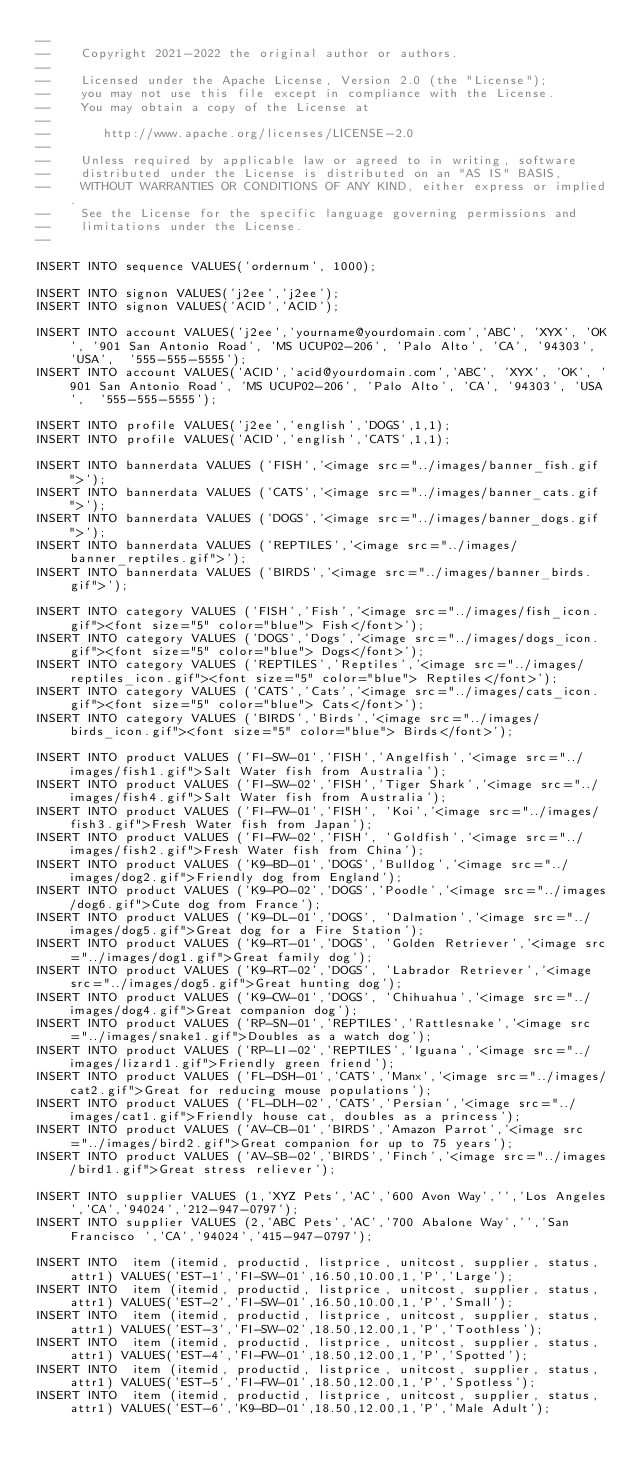Convert code to text. <code><loc_0><loc_0><loc_500><loc_500><_SQL_>--
--    Copyright 2021-2022 the original author or authors.
--
--    Licensed under the Apache License, Version 2.0 (the "License");
--    you may not use this file except in compliance with the License.
--    You may obtain a copy of the License at
--
--       http://www.apache.org/licenses/LICENSE-2.0
--
--    Unless required by applicable law or agreed to in writing, software
--    distributed under the License is distributed on an "AS IS" BASIS,
--    WITHOUT WARRANTIES OR CONDITIONS OF ANY KIND, either express or implied.
--    See the License for the specific language governing permissions and
--    limitations under the License.
--

INSERT INTO sequence VALUES('ordernum', 1000);

INSERT INTO signon VALUES('j2ee','j2ee');
INSERT INTO signon VALUES('ACID','ACID');

INSERT INTO account VALUES('j2ee','yourname@yourdomain.com','ABC', 'XYX', 'OK', '901 San Antonio Road', 'MS UCUP02-206', 'Palo Alto', 'CA', '94303', 'USA',  '555-555-5555');
INSERT INTO account VALUES('ACID','acid@yourdomain.com','ABC', 'XYX', 'OK', '901 San Antonio Road', 'MS UCUP02-206', 'Palo Alto', 'CA', '94303', 'USA',  '555-555-5555');

INSERT INTO profile VALUES('j2ee','english','DOGS',1,1);
INSERT INTO profile VALUES('ACID','english','CATS',1,1);

INSERT INTO bannerdata VALUES ('FISH','<image src="../images/banner_fish.gif">');
INSERT INTO bannerdata VALUES ('CATS','<image src="../images/banner_cats.gif">');
INSERT INTO bannerdata VALUES ('DOGS','<image src="../images/banner_dogs.gif">');
INSERT INTO bannerdata VALUES ('REPTILES','<image src="../images/banner_reptiles.gif">');
INSERT INTO bannerdata VALUES ('BIRDS','<image src="../images/banner_birds.gif">');

INSERT INTO category VALUES ('FISH','Fish','<image src="../images/fish_icon.gif"><font size="5" color="blue"> Fish</font>');
INSERT INTO category VALUES ('DOGS','Dogs','<image src="../images/dogs_icon.gif"><font size="5" color="blue"> Dogs</font>');
INSERT INTO category VALUES ('REPTILES','Reptiles','<image src="../images/reptiles_icon.gif"><font size="5" color="blue"> Reptiles</font>');
INSERT INTO category VALUES ('CATS','Cats','<image src="../images/cats_icon.gif"><font size="5" color="blue"> Cats</font>');
INSERT INTO category VALUES ('BIRDS','Birds','<image src="../images/birds_icon.gif"><font size="5" color="blue"> Birds</font>');

INSERT INTO product VALUES ('FI-SW-01','FISH','Angelfish','<image src="../images/fish1.gif">Salt Water fish from Australia');
INSERT INTO product VALUES ('FI-SW-02','FISH','Tiger Shark','<image src="../images/fish4.gif">Salt Water fish from Australia');
INSERT INTO product VALUES ('FI-FW-01','FISH', 'Koi','<image src="../images/fish3.gif">Fresh Water fish from Japan');
INSERT INTO product VALUES ('FI-FW-02','FISH', 'Goldfish','<image src="../images/fish2.gif">Fresh Water fish from China');
INSERT INTO product VALUES ('K9-BD-01','DOGS','Bulldog','<image src="../images/dog2.gif">Friendly dog from England');
INSERT INTO product VALUES ('K9-PO-02','DOGS','Poodle','<image src="../images/dog6.gif">Cute dog from France');
INSERT INTO product VALUES ('K9-DL-01','DOGS', 'Dalmation','<image src="../images/dog5.gif">Great dog for a Fire Station');
INSERT INTO product VALUES ('K9-RT-01','DOGS', 'Golden Retriever','<image src="../images/dog1.gif">Great family dog');
INSERT INTO product VALUES ('K9-RT-02','DOGS', 'Labrador Retriever','<image src="../images/dog5.gif">Great hunting dog');
INSERT INTO product VALUES ('K9-CW-01','DOGS', 'Chihuahua','<image src="../images/dog4.gif">Great companion dog');
INSERT INTO product VALUES ('RP-SN-01','REPTILES','Rattlesnake','<image src="../images/snake1.gif">Doubles as a watch dog');
INSERT INTO product VALUES ('RP-LI-02','REPTILES','Iguana','<image src="../images/lizard1.gif">Friendly green friend');
INSERT INTO product VALUES ('FL-DSH-01','CATS','Manx','<image src="../images/cat2.gif">Great for reducing mouse populations');
INSERT INTO product VALUES ('FL-DLH-02','CATS','Persian','<image src="../images/cat1.gif">Friendly house cat, doubles as a princess');
INSERT INTO product VALUES ('AV-CB-01','BIRDS','Amazon Parrot','<image src="../images/bird2.gif">Great companion for up to 75 years');
INSERT INTO product VALUES ('AV-SB-02','BIRDS','Finch','<image src="../images/bird1.gif">Great stress reliever');

INSERT INTO supplier VALUES (1,'XYZ Pets','AC','600 Avon Way','','Los Angeles','CA','94024','212-947-0797');
INSERT INTO supplier VALUES (2,'ABC Pets','AC','700 Abalone Way','','San Francisco ','CA','94024','415-947-0797');

INSERT INTO  item (itemid, productid, listprice, unitcost, supplier, status, attr1) VALUES('EST-1','FI-SW-01',16.50,10.00,1,'P','Large');
INSERT INTO  item (itemid, productid, listprice, unitcost, supplier, status, attr1) VALUES('EST-2','FI-SW-01',16.50,10.00,1,'P','Small');
INSERT INTO  item (itemid, productid, listprice, unitcost, supplier, status, attr1) VALUES('EST-3','FI-SW-02',18.50,12.00,1,'P','Toothless');
INSERT INTO  item (itemid, productid, listprice, unitcost, supplier, status, attr1) VALUES('EST-4','FI-FW-01',18.50,12.00,1,'P','Spotted');
INSERT INTO  item (itemid, productid, listprice, unitcost, supplier, status, attr1) VALUES('EST-5','FI-FW-01',18.50,12.00,1,'P','Spotless');
INSERT INTO  item (itemid, productid, listprice, unitcost, supplier, status, attr1) VALUES('EST-6','K9-BD-01',18.50,12.00,1,'P','Male Adult');</code> 